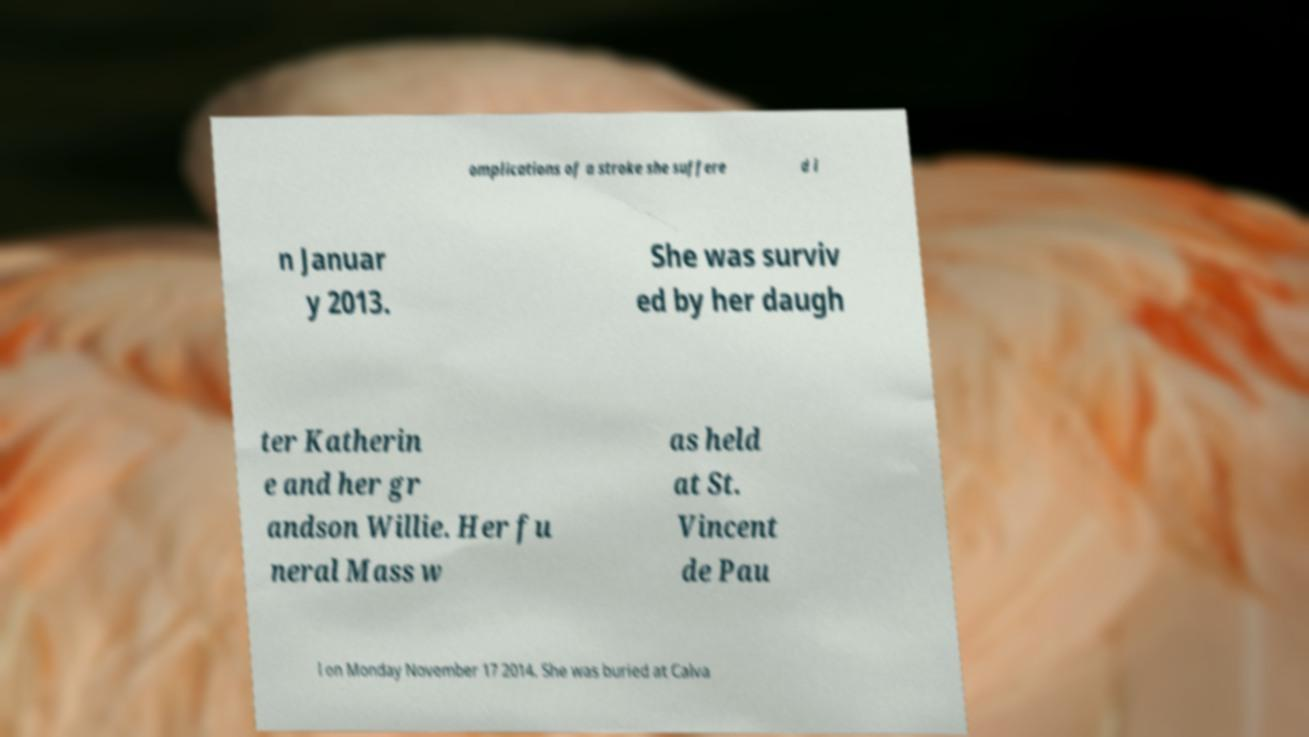I need the written content from this picture converted into text. Can you do that? omplications of a stroke she suffere d i n Januar y 2013. She was surviv ed by her daugh ter Katherin e and her gr andson Willie. Her fu neral Mass w as held at St. Vincent de Pau l on Monday November 17 2014. She was buried at Calva 